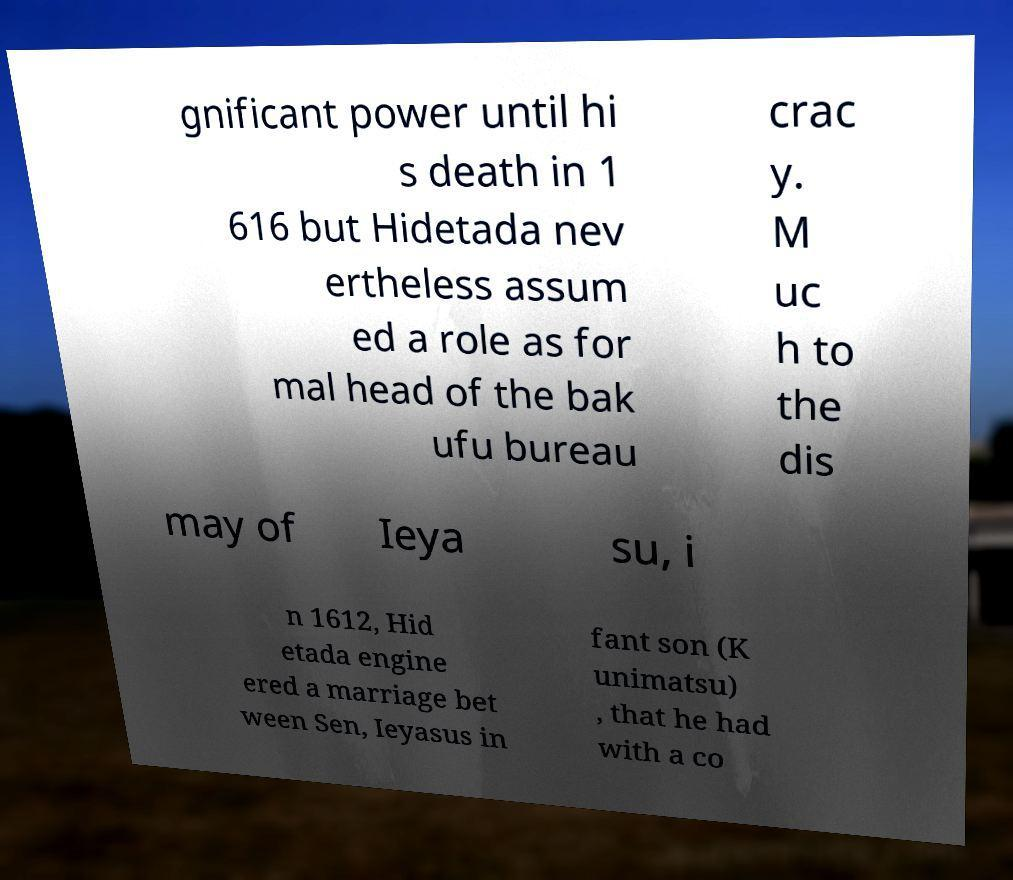Could you extract and type out the text from this image? gnificant power until hi s death in 1 616 but Hidetada nev ertheless assum ed a role as for mal head of the bak ufu bureau crac y. M uc h to the dis may of Ieya su, i n 1612, Hid etada engine ered a marriage bet ween Sen, Ieyasus in fant son (K unimatsu) , that he had with a co 